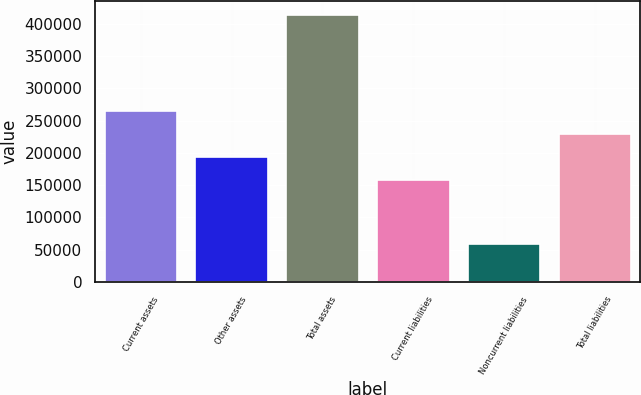Convert chart to OTSL. <chart><loc_0><loc_0><loc_500><loc_500><bar_chart><fcel>Current assets<fcel>Other assets<fcel>Total assets<fcel>Current liabilities<fcel>Noncurrent liabilities<fcel>Total liabilities<nl><fcel>265293<fcel>194169<fcel>414151<fcel>158607<fcel>58532<fcel>229731<nl></chart> 